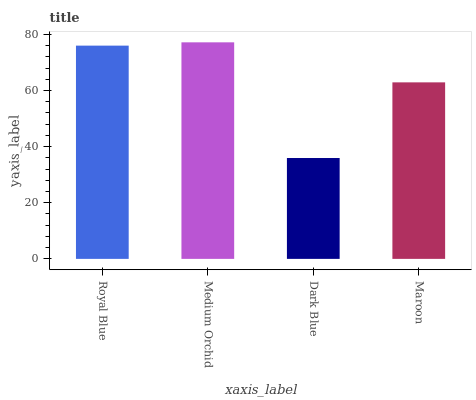Is Dark Blue the minimum?
Answer yes or no. Yes. Is Medium Orchid the maximum?
Answer yes or no. Yes. Is Medium Orchid the minimum?
Answer yes or no. No. Is Dark Blue the maximum?
Answer yes or no. No. Is Medium Orchid greater than Dark Blue?
Answer yes or no. Yes. Is Dark Blue less than Medium Orchid?
Answer yes or no. Yes. Is Dark Blue greater than Medium Orchid?
Answer yes or no. No. Is Medium Orchid less than Dark Blue?
Answer yes or no. No. Is Royal Blue the high median?
Answer yes or no. Yes. Is Maroon the low median?
Answer yes or no. Yes. Is Dark Blue the high median?
Answer yes or no. No. Is Royal Blue the low median?
Answer yes or no. No. 